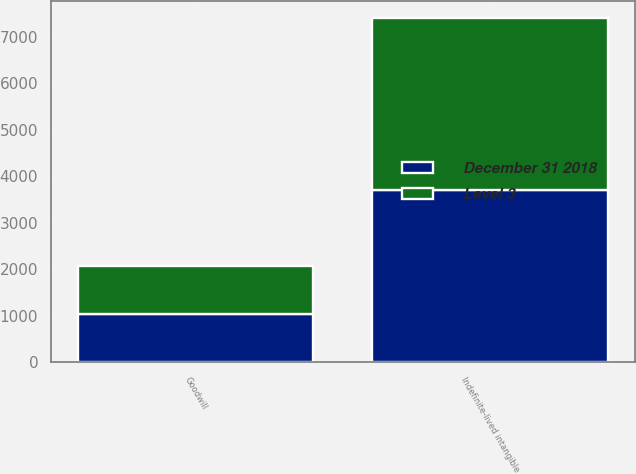Convert chart. <chart><loc_0><loc_0><loc_500><loc_500><stacked_bar_chart><ecel><fcel>Goodwill<fcel>Indefinite-lived intangible<nl><fcel>December 31 2018<fcel>1039.5<fcel>3698<nl><fcel>Level 3<fcel>1039.5<fcel>3698<nl></chart> 